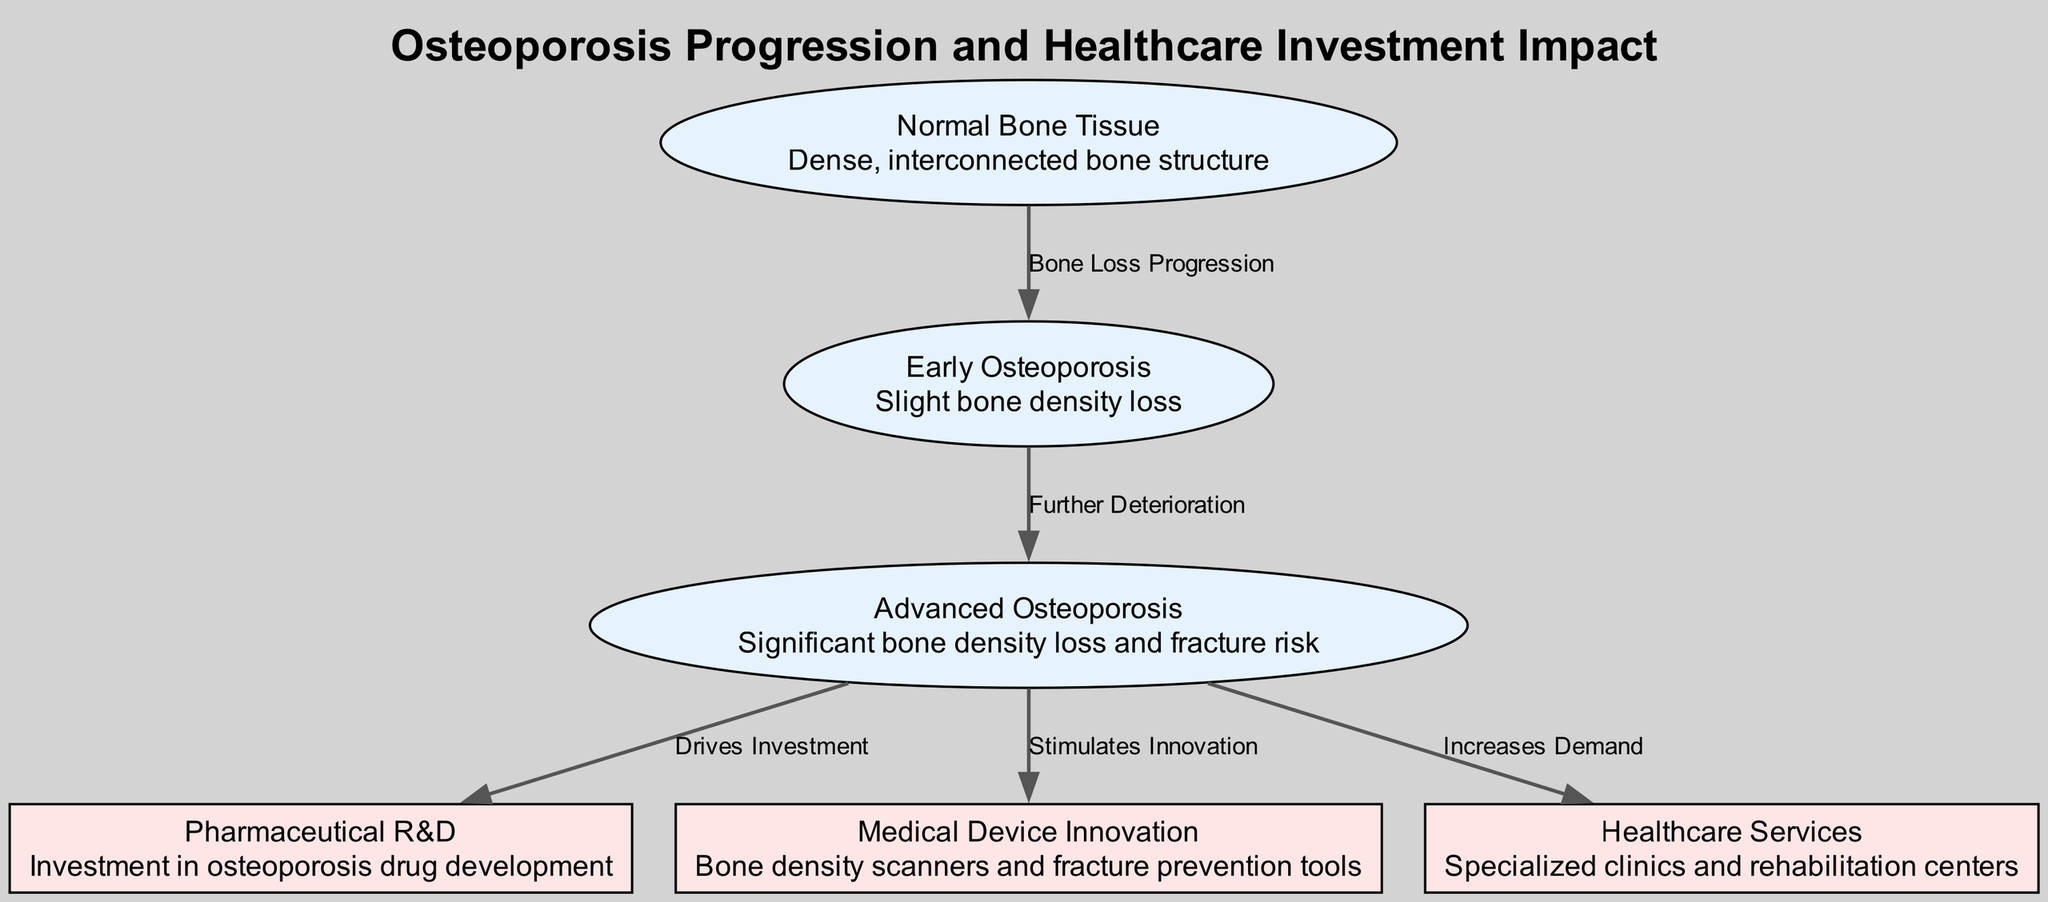What is the relationship between Normal Bone Tissue and Early Osteoporosis? The diagram indicates that Normal Bone Tissue transitions to Early Osteoporosis through the process labeled "Bone Loss Progression." This shows that the progression of bone loss leads to a slight reduction in density.
Answer: Bone Loss Progression How many nodes are present in the diagram? The diagram features six nodes representing different stages of osteoporosis and related healthcare investments. Each node represents a unique aspect of the progression or its impact on healthcare.
Answer: 6 What does the arrow from Advanced Osteoporosis to Pharmaceutical R&D signify? The arrow represents a connection labeled "Drives Investment," indicating that the advanced stage of osteoporosis stimulates investment in the development of osteoporosis drugs. This shows a direct economic impact of the health condition on pharmaceutical R&D.
Answer: Drives Investment Which node represents investment in osteoporosis drug development? The node labeled "Pharmaceutical R&D" specifically refers to the investment dedicated to the development of drugs that target osteoporosis. It is positioned in the diagram to illustrate the response to the advanced stage of the disease.
Answer: Pharmaceutical R&D What is indicated by the edge labeled "Increases Demand"? This edge links Advanced Osteoporosis to Healthcare Services, indicating that as osteoporosis advances and the risk of fractures increases, there is a higher demand for specialized clinics and rehabilitation services. Thus, the healthcare sector responds to the needs generated by the disease's progression.
Answer: Increases Demand What is the description of the Early Osteoporosis node? The Early Osteoporosis node is described as "Slight bone density loss," which illustrates the initial stage of the disease marked by a minimal reduction in bone structure density, indicating the early signs of osteoporosis.
Answer: Slight bone density loss What stimulates innovation in medical devices according to the diagram? The diagram shows that Advanced Osteoporosis stimulates innovation, specifically in the development of medical devices like bone density scanners and tools for fracture prevention. This suggests that the increasing prevalence of osteoporosis necessitates advancements in technology.
Answer: Stimulates Innovation 